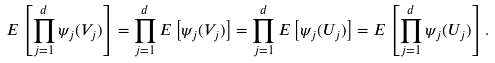Convert formula to latex. <formula><loc_0><loc_0><loc_500><loc_500>E \left [ \prod _ { j = 1 } ^ { d } \psi _ { j } ( V _ { j } ) \right ] = \prod _ { j = 1 } ^ { d } E \left [ \psi _ { j } ( V _ { j } ) \right ] = \prod _ { j = 1 } ^ { d } E \left [ \psi _ { j } ( U _ { j } ) \right ] = E \left [ \prod _ { j = 1 } ^ { d } \psi _ { j } ( U _ { j } ) \right ] .</formula> 